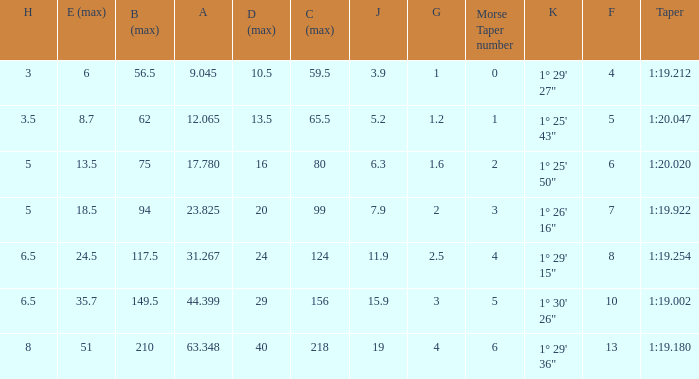Name the h when c max is 99 5.0. 